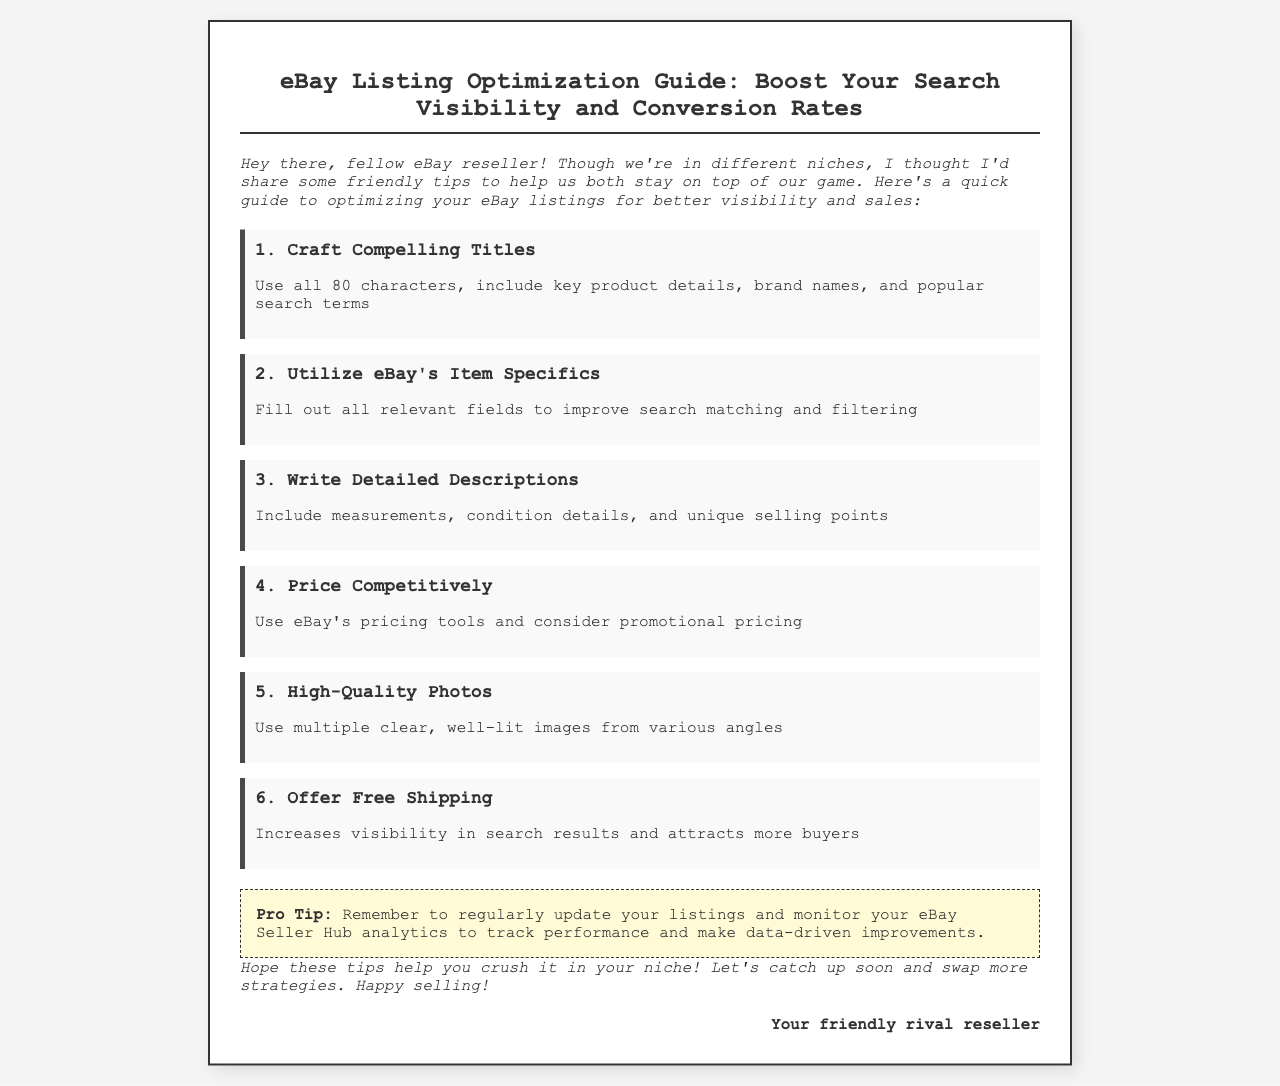What is the title of the guide? The title is displayed prominently at the top of the document.
Answer: eBay Listing Optimization Guide: Boost Your Search Visibility and Conversion Rates How many characters should the titles use? This number is mentioned in the first key step of the guide.
Answer: 80 characters What is one benefit of offering free shipping? The guide mentions this in the sixth key step.
Answer: Increases visibility in search results What is a pro tip provided in the document? The pro tip is highlighted in a separate section of the guide.
Answer: Regularly update your listings Who is the author of the guide? The author identifies themselves in the closing part of the document.
Answer: Your friendly rival reseller 